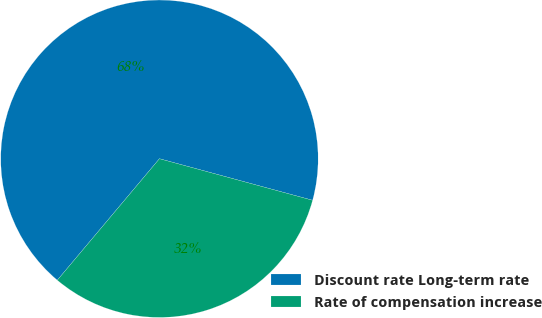Convert chart to OTSL. <chart><loc_0><loc_0><loc_500><loc_500><pie_chart><fcel>Discount rate Long-term rate<fcel>Rate of compensation increase<nl><fcel>68.09%<fcel>31.91%<nl></chart> 